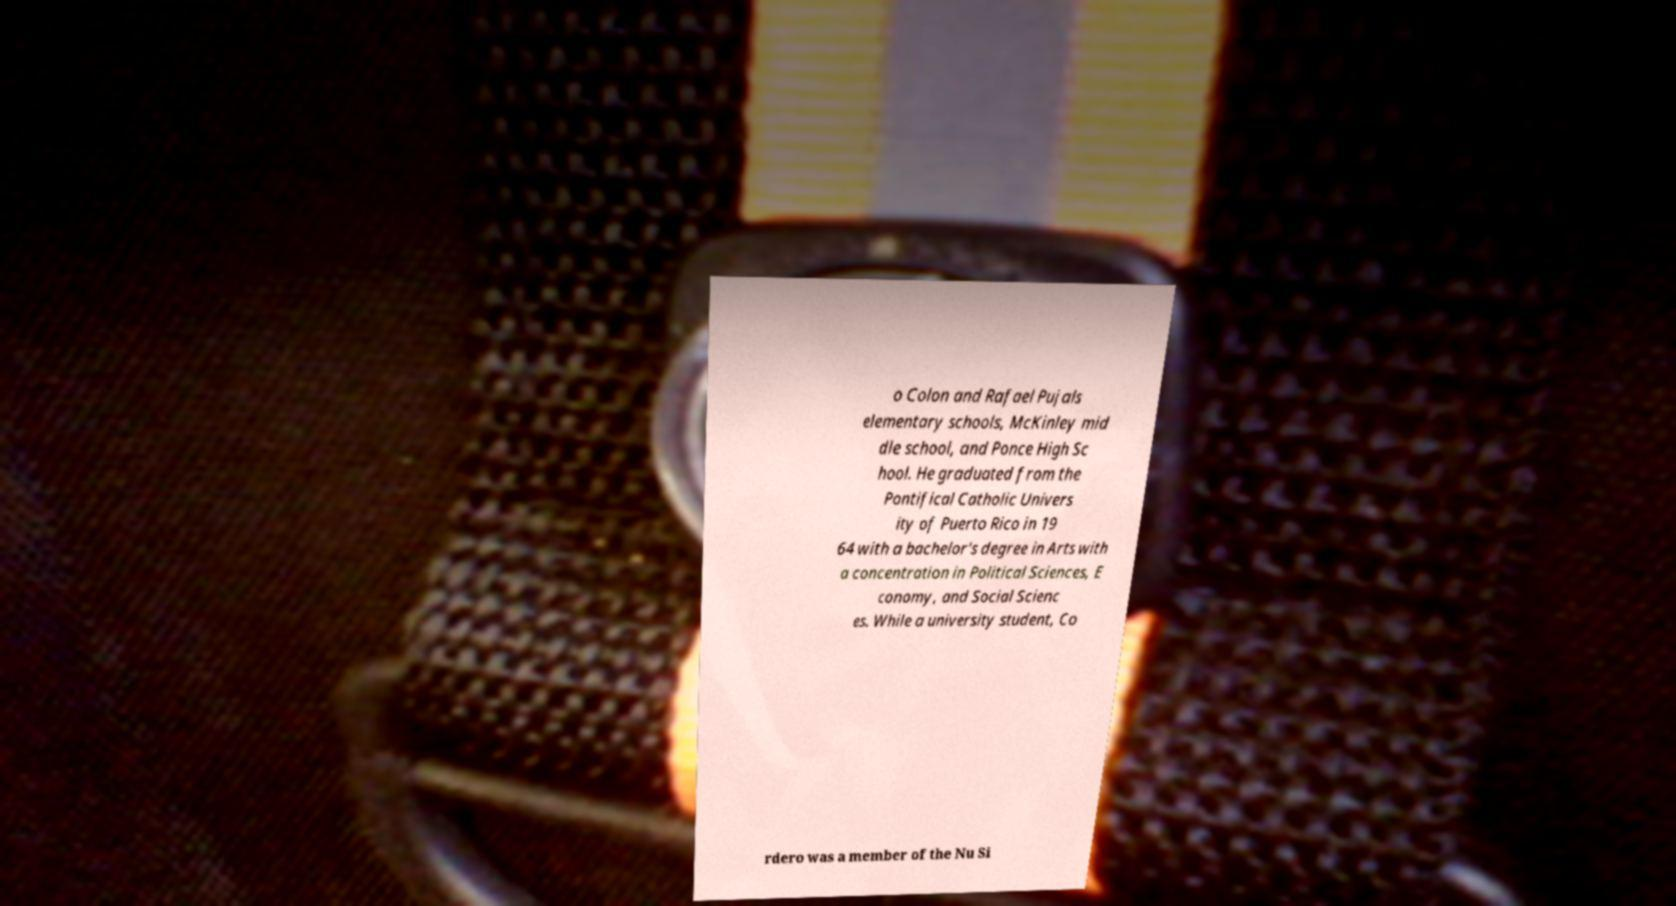I need the written content from this picture converted into text. Can you do that? o Colon and Rafael Pujals elementary schools, McKinley mid dle school, and Ponce High Sc hool. He graduated from the Pontifical Catholic Univers ity of Puerto Rico in 19 64 with a bachelor's degree in Arts with a concentration in Political Sciences, E conomy, and Social Scienc es. While a university student, Co rdero was a member of the Nu Si 